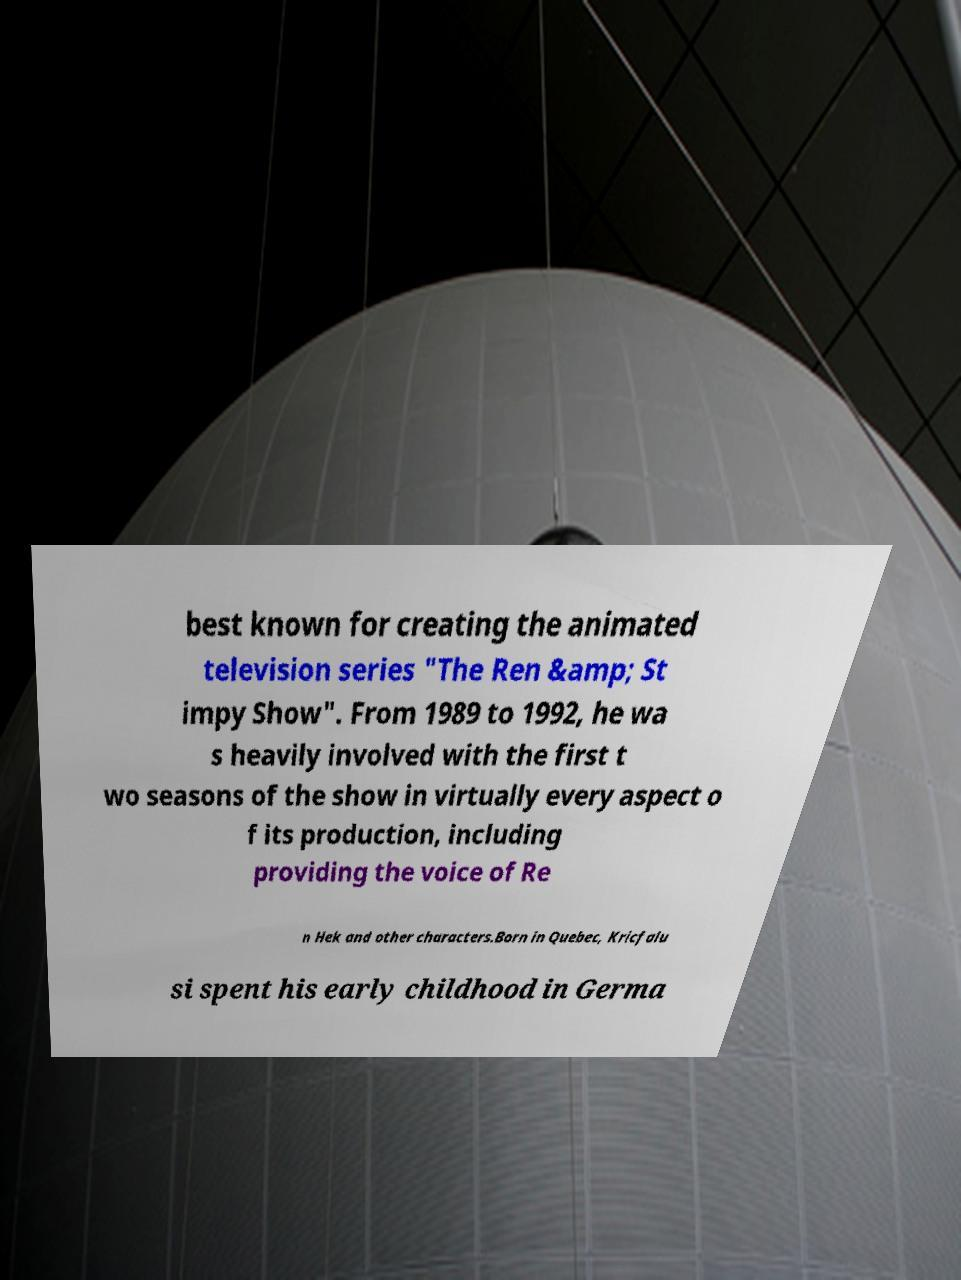Could you extract and type out the text from this image? best known for creating the animated television series "The Ren &amp; St impy Show". From 1989 to 1992, he wa s heavily involved with the first t wo seasons of the show in virtually every aspect o f its production, including providing the voice of Re n Hek and other characters.Born in Quebec, Kricfalu si spent his early childhood in Germa 